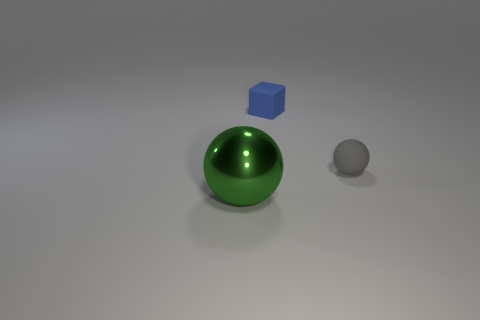Add 3 small gray matte balls. How many objects exist? 6 Subtract all cubes. How many objects are left? 2 Subtract all tiny rubber spheres. Subtract all gray rubber spheres. How many objects are left? 1 Add 1 matte things. How many matte things are left? 3 Add 1 small red rubber cylinders. How many small red rubber cylinders exist? 1 Subtract 0 blue cylinders. How many objects are left? 3 